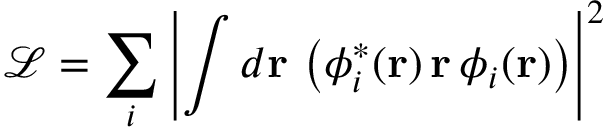Convert formula to latex. <formula><loc_0><loc_0><loc_500><loc_500>\mathcal { L } = \sum _ { i } \left | \int d r \, \left ( \phi _ { i } ^ { \ast } ( r ) \, r \, \phi _ { i } ( r ) \right ) \right | ^ { 2 }</formula> 